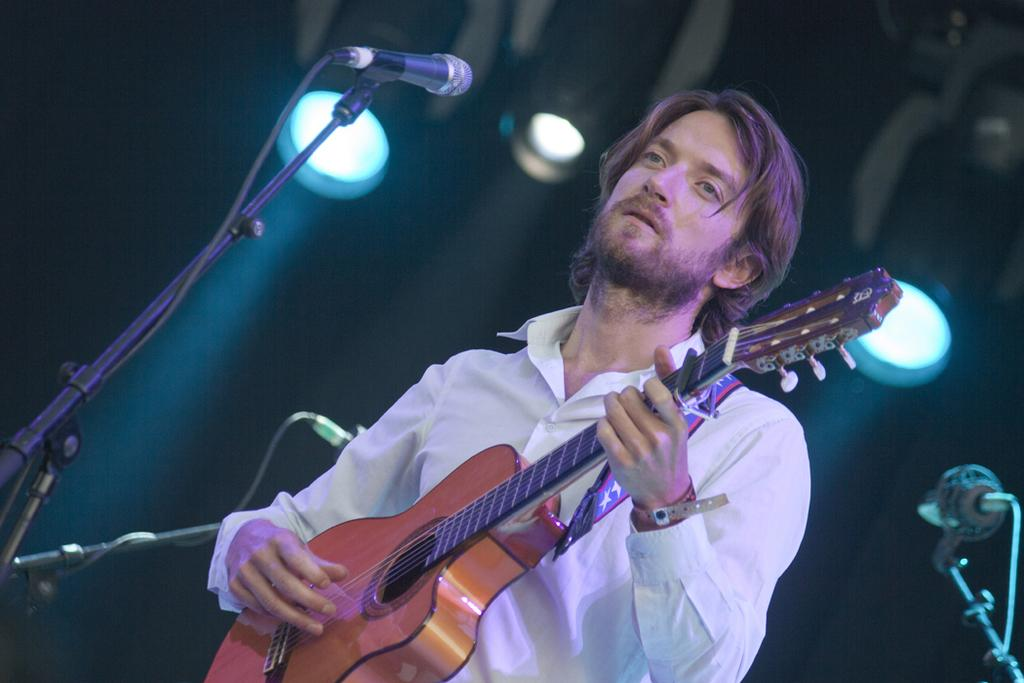Who is the main subject in the image? There is a man in the image. What is the man doing in the image? The man is playing a guitar. What object is in front of the man? There is a microphone in front of the man. What can be seen behind the man in the image? There are lights visible behind the man. What type of jewel is the man wearing on his head in the image? There is no jewel visible on the man's head in the image. 